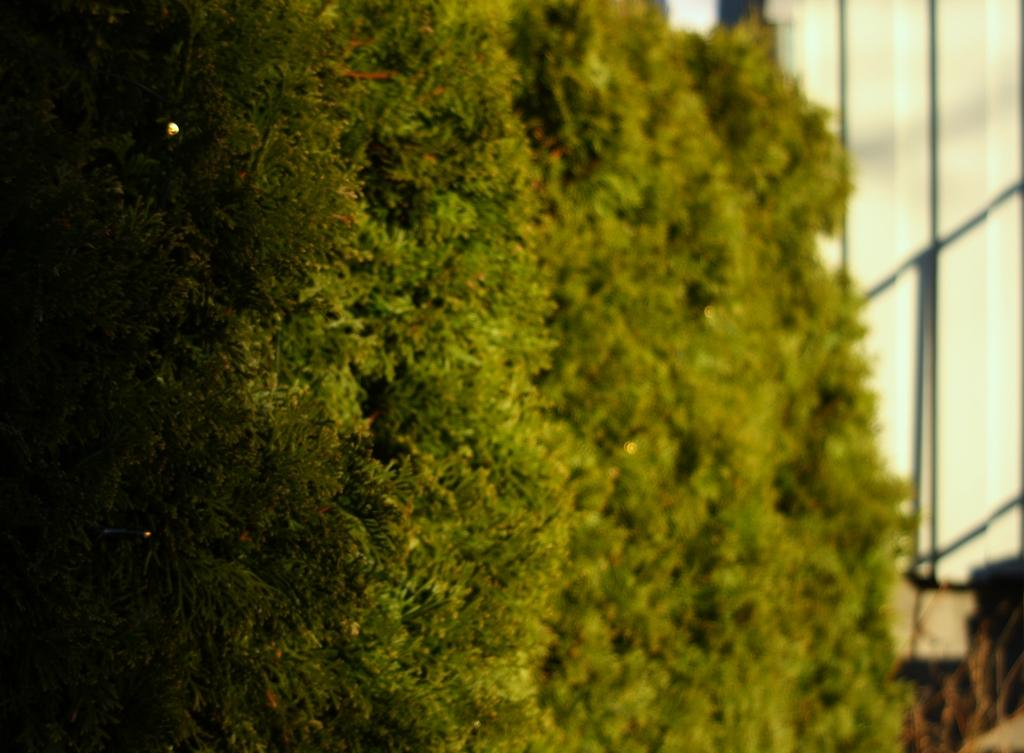What type of vegetation can be seen in the image? There are trees present in the image. What type of hose is connected to the tree in the image? There is no hose connected to the tree in the image; only trees are present. 